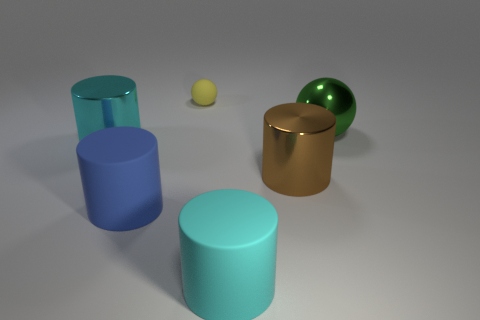Subtract all cyan cylinders. Subtract all brown balls. How many cylinders are left? 2 Add 3 big matte cylinders. How many objects exist? 9 Subtract all spheres. How many objects are left? 4 Subtract all big green metal spheres. Subtract all small yellow objects. How many objects are left? 4 Add 1 large green spheres. How many large green spheres are left? 2 Add 1 small yellow balls. How many small yellow balls exist? 2 Subtract 0 gray cylinders. How many objects are left? 6 